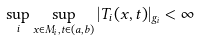<formula> <loc_0><loc_0><loc_500><loc_500>\sup _ { i } \sup _ { x \in M _ { i } , t \in ( a , b ) } | T _ { i } ( x , t ) | _ { g _ { i } } < \infty</formula> 